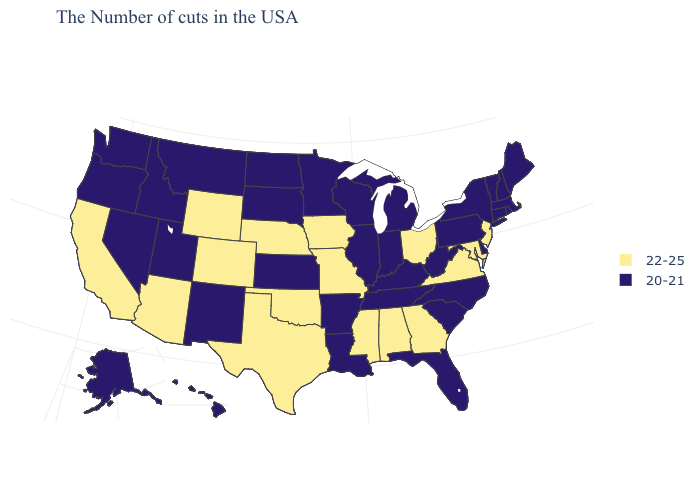What is the highest value in the MidWest ?
Be succinct. 22-25. Is the legend a continuous bar?
Answer briefly. No. What is the lowest value in the West?
Write a very short answer. 20-21. Name the states that have a value in the range 22-25?
Answer briefly. New Jersey, Maryland, Virginia, Ohio, Georgia, Alabama, Mississippi, Missouri, Iowa, Nebraska, Oklahoma, Texas, Wyoming, Colorado, Arizona, California. What is the value of Washington?
Answer briefly. 20-21. Does Alaska have the lowest value in the USA?
Keep it brief. Yes. Does Georgia have the same value as Nebraska?
Short answer required. Yes. Name the states that have a value in the range 20-21?
Keep it brief. Maine, Massachusetts, Rhode Island, New Hampshire, Vermont, Connecticut, New York, Delaware, Pennsylvania, North Carolina, South Carolina, West Virginia, Florida, Michigan, Kentucky, Indiana, Tennessee, Wisconsin, Illinois, Louisiana, Arkansas, Minnesota, Kansas, South Dakota, North Dakota, New Mexico, Utah, Montana, Idaho, Nevada, Washington, Oregon, Alaska, Hawaii. Which states have the lowest value in the USA?
Answer briefly. Maine, Massachusetts, Rhode Island, New Hampshire, Vermont, Connecticut, New York, Delaware, Pennsylvania, North Carolina, South Carolina, West Virginia, Florida, Michigan, Kentucky, Indiana, Tennessee, Wisconsin, Illinois, Louisiana, Arkansas, Minnesota, Kansas, South Dakota, North Dakota, New Mexico, Utah, Montana, Idaho, Nevada, Washington, Oregon, Alaska, Hawaii. Does the first symbol in the legend represent the smallest category?
Give a very brief answer. No. Does California have the lowest value in the USA?
Short answer required. No. What is the value of Nebraska?
Answer briefly. 22-25. What is the value of California?
Give a very brief answer. 22-25. Name the states that have a value in the range 20-21?
Keep it brief. Maine, Massachusetts, Rhode Island, New Hampshire, Vermont, Connecticut, New York, Delaware, Pennsylvania, North Carolina, South Carolina, West Virginia, Florida, Michigan, Kentucky, Indiana, Tennessee, Wisconsin, Illinois, Louisiana, Arkansas, Minnesota, Kansas, South Dakota, North Dakota, New Mexico, Utah, Montana, Idaho, Nevada, Washington, Oregon, Alaska, Hawaii. 